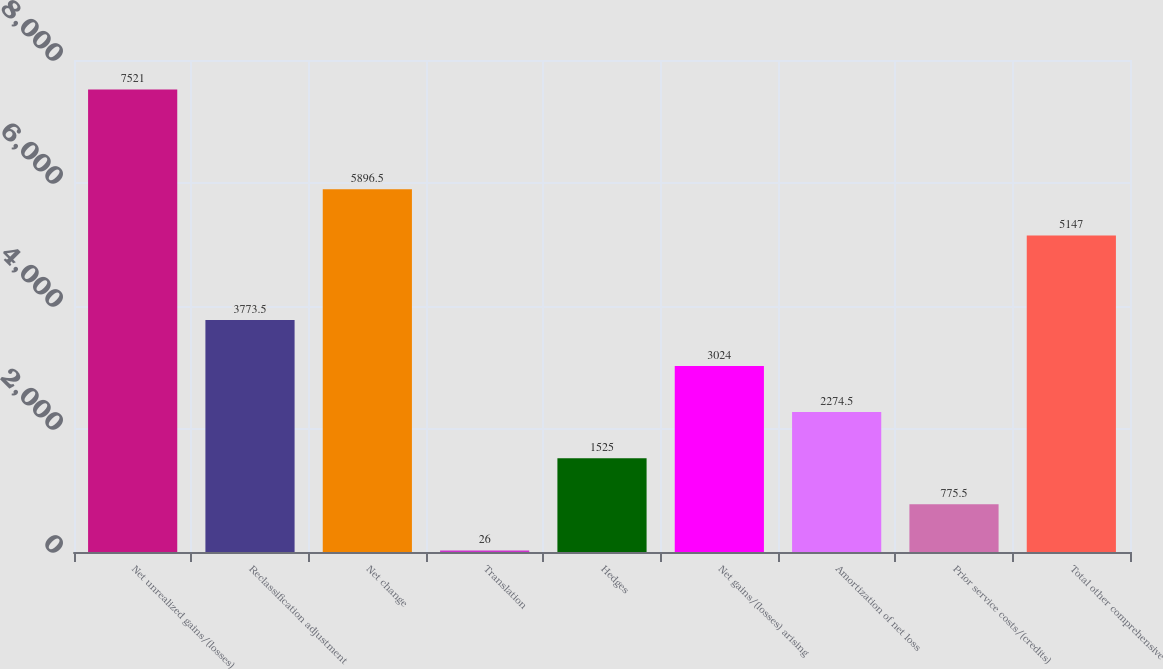Convert chart to OTSL. <chart><loc_0><loc_0><loc_500><loc_500><bar_chart><fcel>Net unrealized gains/(losses)<fcel>Reclassification adjustment<fcel>Net change<fcel>Translation<fcel>Hedges<fcel>Net gains/(losses) arising<fcel>Amortization of net loss<fcel>Prior service costs/(credits)<fcel>Total other comprehensive<nl><fcel>7521<fcel>3773.5<fcel>5896.5<fcel>26<fcel>1525<fcel>3024<fcel>2274.5<fcel>775.5<fcel>5147<nl></chart> 